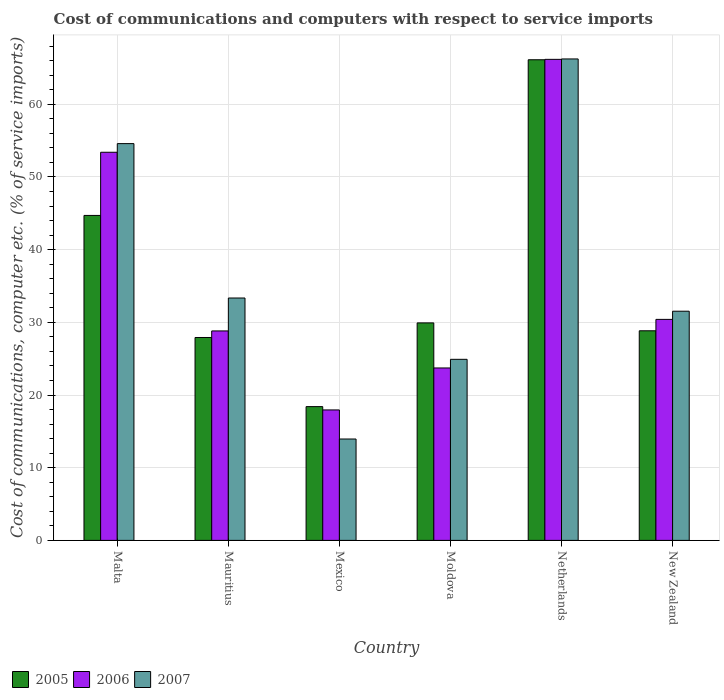How many groups of bars are there?
Your answer should be very brief. 6. How many bars are there on the 6th tick from the left?
Your answer should be very brief. 3. What is the label of the 2nd group of bars from the left?
Offer a terse response. Mauritius. In how many cases, is the number of bars for a given country not equal to the number of legend labels?
Offer a terse response. 0. What is the cost of communications and computers in 2006 in Mexico?
Your answer should be very brief. 17.95. Across all countries, what is the maximum cost of communications and computers in 2007?
Provide a succinct answer. 66.23. Across all countries, what is the minimum cost of communications and computers in 2005?
Offer a terse response. 18.4. In which country was the cost of communications and computers in 2005 minimum?
Offer a very short reply. Mexico. What is the total cost of communications and computers in 2006 in the graph?
Ensure brevity in your answer.  220.46. What is the difference between the cost of communications and computers in 2007 in Moldova and that in Netherlands?
Provide a succinct answer. -41.32. What is the difference between the cost of communications and computers in 2005 in Mexico and the cost of communications and computers in 2007 in Mauritius?
Provide a short and direct response. -14.94. What is the average cost of communications and computers in 2006 per country?
Your answer should be compact. 36.74. What is the difference between the cost of communications and computers of/in 2006 and cost of communications and computers of/in 2005 in Malta?
Give a very brief answer. 8.69. In how many countries, is the cost of communications and computers in 2007 greater than 34 %?
Give a very brief answer. 2. What is the ratio of the cost of communications and computers in 2007 in Mexico to that in Moldova?
Make the answer very short. 0.56. Is the difference between the cost of communications and computers in 2006 in Moldova and New Zealand greater than the difference between the cost of communications and computers in 2005 in Moldova and New Zealand?
Your response must be concise. No. What is the difference between the highest and the second highest cost of communications and computers in 2005?
Your answer should be compact. 21.42. What is the difference between the highest and the lowest cost of communications and computers in 2005?
Offer a terse response. 47.72. What does the 2nd bar from the left in Mexico represents?
Make the answer very short. 2006. What is the difference between two consecutive major ticks on the Y-axis?
Keep it short and to the point. 10. Are the values on the major ticks of Y-axis written in scientific E-notation?
Offer a terse response. No. How many legend labels are there?
Provide a short and direct response. 3. How are the legend labels stacked?
Provide a short and direct response. Horizontal. What is the title of the graph?
Keep it short and to the point. Cost of communications and computers with respect to service imports. What is the label or title of the Y-axis?
Ensure brevity in your answer.  Cost of communications, computer etc. (% of service imports). What is the Cost of communications, computer etc. (% of service imports) in 2005 in Malta?
Offer a terse response. 44.71. What is the Cost of communications, computer etc. (% of service imports) of 2006 in Malta?
Your response must be concise. 53.4. What is the Cost of communications, computer etc. (% of service imports) of 2007 in Malta?
Your answer should be compact. 54.58. What is the Cost of communications, computer etc. (% of service imports) in 2005 in Mauritius?
Your answer should be very brief. 27.91. What is the Cost of communications, computer etc. (% of service imports) of 2006 in Mauritius?
Your answer should be very brief. 28.82. What is the Cost of communications, computer etc. (% of service imports) in 2007 in Mauritius?
Your answer should be very brief. 33.35. What is the Cost of communications, computer etc. (% of service imports) of 2005 in Mexico?
Your answer should be compact. 18.4. What is the Cost of communications, computer etc. (% of service imports) in 2006 in Mexico?
Offer a terse response. 17.95. What is the Cost of communications, computer etc. (% of service imports) in 2007 in Mexico?
Give a very brief answer. 13.95. What is the Cost of communications, computer etc. (% of service imports) in 2005 in Moldova?
Your answer should be compact. 29.92. What is the Cost of communications, computer etc. (% of service imports) in 2006 in Moldova?
Offer a terse response. 23.72. What is the Cost of communications, computer etc. (% of service imports) in 2007 in Moldova?
Offer a very short reply. 24.91. What is the Cost of communications, computer etc. (% of service imports) in 2005 in Netherlands?
Your answer should be very brief. 66.12. What is the Cost of communications, computer etc. (% of service imports) of 2006 in Netherlands?
Your response must be concise. 66.18. What is the Cost of communications, computer etc. (% of service imports) of 2007 in Netherlands?
Offer a terse response. 66.23. What is the Cost of communications, computer etc. (% of service imports) in 2005 in New Zealand?
Provide a short and direct response. 28.84. What is the Cost of communications, computer etc. (% of service imports) in 2006 in New Zealand?
Keep it short and to the point. 30.4. What is the Cost of communications, computer etc. (% of service imports) of 2007 in New Zealand?
Make the answer very short. 31.53. Across all countries, what is the maximum Cost of communications, computer etc. (% of service imports) in 2005?
Your response must be concise. 66.12. Across all countries, what is the maximum Cost of communications, computer etc. (% of service imports) in 2006?
Your answer should be very brief. 66.18. Across all countries, what is the maximum Cost of communications, computer etc. (% of service imports) of 2007?
Give a very brief answer. 66.23. Across all countries, what is the minimum Cost of communications, computer etc. (% of service imports) in 2005?
Offer a very short reply. 18.4. Across all countries, what is the minimum Cost of communications, computer etc. (% of service imports) in 2006?
Your answer should be compact. 17.95. Across all countries, what is the minimum Cost of communications, computer etc. (% of service imports) of 2007?
Make the answer very short. 13.95. What is the total Cost of communications, computer etc. (% of service imports) of 2005 in the graph?
Provide a succinct answer. 215.9. What is the total Cost of communications, computer etc. (% of service imports) in 2006 in the graph?
Provide a succinct answer. 220.46. What is the total Cost of communications, computer etc. (% of service imports) of 2007 in the graph?
Provide a succinct answer. 224.55. What is the difference between the Cost of communications, computer etc. (% of service imports) in 2005 in Malta and that in Mauritius?
Your answer should be very brief. 16.79. What is the difference between the Cost of communications, computer etc. (% of service imports) of 2006 in Malta and that in Mauritius?
Make the answer very short. 24.58. What is the difference between the Cost of communications, computer etc. (% of service imports) in 2007 in Malta and that in Mauritius?
Make the answer very short. 21.24. What is the difference between the Cost of communications, computer etc. (% of service imports) in 2005 in Malta and that in Mexico?
Your answer should be compact. 26.3. What is the difference between the Cost of communications, computer etc. (% of service imports) of 2006 in Malta and that in Mexico?
Make the answer very short. 35.45. What is the difference between the Cost of communications, computer etc. (% of service imports) of 2007 in Malta and that in Mexico?
Your answer should be compact. 40.64. What is the difference between the Cost of communications, computer etc. (% of service imports) of 2005 in Malta and that in Moldova?
Keep it short and to the point. 14.79. What is the difference between the Cost of communications, computer etc. (% of service imports) of 2006 in Malta and that in Moldova?
Offer a very short reply. 29.67. What is the difference between the Cost of communications, computer etc. (% of service imports) in 2007 in Malta and that in Moldova?
Ensure brevity in your answer.  29.67. What is the difference between the Cost of communications, computer etc. (% of service imports) of 2005 in Malta and that in Netherlands?
Ensure brevity in your answer.  -21.42. What is the difference between the Cost of communications, computer etc. (% of service imports) in 2006 in Malta and that in Netherlands?
Provide a succinct answer. -12.78. What is the difference between the Cost of communications, computer etc. (% of service imports) of 2007 in Malta and that in Netherlands?
Provide a short and direct response. -11.65. What is the difference between the Cost of communications, computer etc. (% of service imports) in 2005 in Malta and that in New Zealand?
Make the answer very short. 15.87. What is the difference between the Cost of communications, computer etc. (% of service imports) of 2006 in Malta and that in New Zealand?
Keep it short and to the point. 22.99. What is the difference between the Cost of communications, computer etc. (% of service imports) in 2007 in Malta and that in New Zealand?
Your answer should be very brief. 23.06. What is the difference between the Cost of communications, computer etc. (% of service imports) of 2005 in Mauritius and that in Mexico?
Offer a very short reply. 9.51. What is the difference between the Cost of communications, computer etc. (% of service imports) in 2006 in Mauritius and that in Mexico?
Give a very brief answer. 10.87. What is the difference between the Cost of communications, computer etc. (% of service imports) in 2007 in Mauritius and that in Mexico?
Your response must be concise. 19.4. What is the difference between the Cost of communications, computer etc. (% of service imports) of 2005 in Mauritius and that in Moldova?
Keep it short and to the point. -2.01. What is the difference between the Cost of communications, computer etc. (% of service imports) in 2006 in Mauritius and that in Moldova?
Provide a succinct answer. 5.09. What is the difference between the Cost of communications, computer etc. (% of service imports) in 2007 in Mauritius and that in Moldova?
Your response must be concise. 8.44. What is the difference between the Cost of communications, computer etc. (% of service imports) in 2005 in Mauritius and that in Netherlands?
Give a very brief answer. -38.21. What is the difference between the Cost of communications, computer etc. (% of service imports) in 2006 in Mauritius and that in Netherlands?
Your answer should be very brief. -37.36. What is the difference between the Cost of communications, computer etc. (% of service imports) of 2007 in Mauritius and that in Netherlands?
Your answer should be very brief. -32.89. What is the difference between the Cost of communications, computer etc. (% of service imports) in 2005 in Mauritius and that in New Zealand?
Give a very brief answer. -0.92. What is the difference between the Cost of communications, computer etc. (% of service imports) in 2006 in Mauritius and that in New Zealand?
Ensure brevity in your answer.  -1.59. What is the difference between the Cost of communications, computer etc. (% of service imports) in 2007 in Mauritius and that in New Zealand?
Your response must be concise. 1.82. What is the difference between the Cost of communications, computer etc. (% of service imports) of 2005 in Mexico and that in Moldova?
Your response must be concise. -11.52. What is the difference between the Cost of communications, computer etc. (% of service imports) of 2006 in Mexico and that in Moldova?
Your answer should be very brief. -5.77. What is the difference between the Cost of communications, computer etc. (% of service imports) of 2007 in Mexico and that in Moldova?
Your response must be concise. -10.96. What is the difference between the Cost of communications, computer etc. (% of service imports) of 2005 in Mexico and that in Netherlands?
Make the answer very short. -47.72. What is the difference between the Cost of communications, computer etc. (% of service imports) in 2006 in Mexico and that in Netherlands?
Ensure brevity in your answer.  -48.23. What is the difference between the Cost of communications, computer etc. (% of service imports) of 2007 in Mexico and that in Netherlands?
Provide a short and direct response. -52.29. What is the difference between the Cost of communications, computer etc. (% of service imports) of 2005 in Mexico and that in New Zealand?
Offer a terse response. -10.43. What is the difference between the Cost of communications, computer etc. (% of service imports) of 2006 in Mexico and that in New Zealand?
Your answer should be very brief. -12.46. What is the difference between the Cost of communications, computer etc. (% of service imports) in 2007 in Mexico and that in New Zealand?
Keep it short and to the point. -17.58. What is the difference between the Cost of communications, computer etc. (% of service imports) of 2005 in Moldova and that in Netherlands?
Offer a very short reply. -36.2. What is the difference between the Cost of communications, computer etc. (% of service imports) of 2006 in Moldova and that in Netherlands?
Provide a short and direct response. -42.46. What is the difference between the Cost of communications, computer etc. (% of service imports) in 2007 in Moldova and that in Netherlands?
Give a very brief answer. -41.32. What is the difference between the Cost of communications, computer etc. (% of service imports) of 2005 in Moldova and that in New Zealand?
Your response must be concise. 1.08. What is the difference between the Cost of communications, computer etc. (% of service imports) in 2006 in Moldova and that in New Zealand?
Offer a terse response. -6.68. What is the difference between the Cost of communications, computer etc. (% of service imports) of 2007 in Moldova and that in New Zealand?
Your answer should be compact. -6.62. What is the difference between the Cost of communications, computer etc. (% of service imports) in 2005 in Netherlands and that in New Zealand?
Offer a terse response. 37.29. What is the difference between the Cost of communications, computer etc. (% of service imports) in 2006 in Netherlands and that in New Zealand?
Your answer should be very brief. 35.77. What is the difference between the Cost of communications, computer etc. (% of service imports) of 2007 in Netherlands and that in New Zealand?
Your answer should be very brief. 34.7. What is the difference between the Cost of communications, computer etc. (% of service imports) in 2005 in Malta and the Cost of communications, computer etc. (% of service imports) in 2006 in Mauritius?
Give a very brief answer. 15.89. What is the difference between the Cost of communications, computer etc. (% of service imports) in 2005 in Malta and the Cost of communications, computer etc. (% of service imports) in 2007 in Mauritius?
Your answer should be very brief. 11.36. What is the difference between the Cost of communications, computer etc. (% of service imports) of 2006 in Malta and the Cost of communications, computer etc. (% of service imports) of 2007 in Mauritius?
Your response must be concise. 20.05. What is the difference between the Cost of communications, computer etc. (% of service imports) of 2005 in Malta and the Cost of communications, computer etc. (% of service imports) of 2006 in Mexico?
Your answer should be compact. 26.76. What is the difference between the Cost of communications, computer etc. (% of service imports) of 2005 in Malta and the Cost of communications, computer etc. (% of service imports) of 2007 in Mexico?
Offer a very short reply. 30.76. What is the difference between the Cost of communications, computer etc. (% of service imports) in 2006 in Malta and the Cost of communications, computer etc. (% of service imports) in 2007 in Mexico?
Your answer should be very brief. 39.45. What is the difference between the Cost of communications, computer etc. (% of service imports) in 2005 in Malta and the Cost of communications, computer etc. (% of service imports) in 2006 in Moldova?
Give a very brief answer. 20.99. What is the difference between the Cost of communications, computer etc. (% of service imports) of 2005 in Malta and the Cost of communications, computer etc. (% of service imports) of 2007 in Moldova?
Your answer should be compact. 19.8. What is the difference between the Cost of communications, computer etc. (% of service imports) in 2006 in Malta and the Cost of communications, computer etc. (% of service imports) in 2007 in Moldova?
Your answer should be compact. 28.49. What is the difference between the Cost of communications, computer etc. (% of service imports) in 2005 in Malta and the Cost of communications, computer etc. (% of service imports) in 2006 in Netherlands?
Your answer should be very brief. -21.47. What is the difference between the Cost of communications, computer etc. (% of service imports) in 2005 in Malta and the Cost of communications, computer etc. (% of service imports) in 2007 in Netherlands?
Offer a terse response. -21.53. What is the difference between the Cost of communications, computer etc. (% of service imports) in 2006 in Malta and the Cost of communications, computer etc. (% of service imports) in 2007 in Netherlands?
Ensure brevity in your answer.  -12.84. What is the difference between the Cost of communications, computer etc. (% of service imports) in 2005 in Malta and the Cost of communications, computer etc. (% of service imports) in 2006 in New Zealand?
Give a very brief answer. 14.3. What is the difference between the Cost of communications, computer etc. (% of service imports) of 2005 in Malta and the Cost of communications, computer etc. (% of service imports) of 2007 in New Zealand?
Offer a terse response. 13.18. What is the difference between the Cost of communications, computer etc. (% of service imports) of 2006 in Malta and the Cost of communications, computer etc. (% of service imports) of 2007 in New Zealand?
Provide a short and direct response. 21.87. What is the difference between the Cost of communications, computer etc. (% of service imports) of 2005 in Mauritius and the Cost of communications, computer etc. (% of service imports) of 2006 in Mexico?
Give a very brief answer. 9.97. What is the difference between the Cost of communications, computer etc. (% of service imports) of 2005 in Mauritius and the Cost of communications, computer etc. (% of service imports) of 2007 in Mexico?
Offer a terse response. 13.97. What is the difference between the Cost of communications, computer etc. (% of service imports) in 2006 in Mauritius and the Cost of communications, computer etc. (% of service imports) in 2007 in Mexico?
Your response must be concise. 14.87. What is the difference between the Cost of communications, computer etc. (% of service imports) in 2005 in Mauritius and the Cost of communications, computer etc. (% of service imports) in 2006 in Moldova?
Your response must be concise. 4.19. What is the difference between the Cost of communications, computer etc. (% of service imports) of 2005 in Mauritius and the Cost of communications, computer etc. (% of service imports) of 2007 in Moldova?
Give a very brief answer. 3. What is the difference between the Cost of communications, computer etc. (% of service imports) in 2006 in Mauritius and the Cost of communications, computer etc. (% of service imports) in 2007 in Moldova?
Provide a short and direct response. 3.91. What is the difference between the Cost of communications, computer etc. (% of service imports) of 2005 in Mauritius and the Cost of communications, computer etc. (% of service imports) of 2006 in Netherlands?
Offer a terse response. -38.26. What is the difference between the Cost of communications, computer etc. (% of service imports) in 2005 in Mauritius and the Cost of communications, computer etc. (% of service imports) in 2007 in Netherlands?
Provide a succinct answer. -38.32. What is the difference between the Cost of communications, computer etc. (% of service imports) in 2006 in Mauritius and the Cost of communications, computer etc. (% of service imports) in 2007 in Netherlands?
Ensure brevity in your answer.  -37.42. What is the difference between the Cost of communications, computer etc. (% of service imports) in 2005 in Mauritius and the Cost of communications, computer etc. (% of service imports) in 2006 in New Zealand?
Offer a terse response. -2.49. What is the difference between the Cost of communications, computer etc. (% of service imports) in 2005 in Mauritius and the Cost of communications, computer etc. (% of service imports) in 2007 in New Zealand?
Ensure brevity in your answer.  -3.61. What is the difference between the Cost of communications, computer etc. (% of service imports) of 2006 in Mauritius and the Cost of communications, computer etc. (% of service imports) of 2007 in New Zealand?
Your answer should be very brief. -2.71. What is the difference between the Cost of communications, computer etc. (% of service imports) of 2005 in Mexico and the Cost of communications, computer etc. (% of service imports) of 2006 in Moldova?
Offer a terse response. -5.32. What is the difference between the Cost of communications, computer etc. (% of service imports) in 2005 in Mexico and the Cost of communications, computer etc. (% of service imports) in 2007 in Moldova?
Offer a very short reply. -6.51. What is the difference between the Cost of communications, computer etc. (% of service imports) of 2006 in Mexico and the Cost of communications, computer etc. (% of service imports) of 2007 in Moldova?
Ensure brevity in your answer.  -6.96. What is the difference between the Cost of communications, computer etc. (% of service imports) of 2005 in Mexico and the Cost of communications, computer etc. (% of service imports) of 2006 in Netherlands?
Your response must be concise. -47.77. What is the difference between the Cost of communications, computer etc. (% of service imports) of 2005 in Mexico and the Cost of communications, computer etc. (% of service imports) of 2007 in Netherlands?
Ensure brevity in your answer.  -47.83. What is the difference between the Cost of communications, computer etc. (% of service imports) in 2006 in Mexico and the Cost of communications, computer etc. (% of service imports) in 2007 in Netherlands?
Keep it short and to the point. -48.29. What is the difference between the Cost of communications, computer etc. (% of service imports) in 2005 in Mexico and the Cost of communications, computer etc. (% of service imports) in 2006 in New Zealand?
Keep it short and to the point. -12. What is the difference between the Cost of communications, computer etc. (% of service imports) in 2005 in Mexico and the Cost of communications, computer etc. (% of service imports) in 2007 in New Zealand?
Your answer should be very brief. -13.13. What is the difference between the Cost of communications, computer etc. (% of service imports) in 2006 in Mexico and the Cost of communications, computer etc. (% of service imports) in 2007 in New Zealand?
Your answer should be compact. -13.58. What is the difference between the Cost of communications, computer etc. (% of service imports) of 2005 in Moldova and the Cost of communications, computer etc. (% of service imports) of 2006 in Netherlands?
Offer a very short reply. -36.26. What is the difference between the Cost of communications, computer etc. (% of service imports) of 2005 in Moldova and the Cost of communications, computer etc. (% of service imports) of 2007 in Netherlands?
Offer a very short reply. -36.31. What is the difference between the Cost of communications, computer etc. (% of service imports) in 2006 in Moldova and the Cost of communications, computer etc. (% of service imports) in 2007 in Netherlands?
Make the answer very short. -42.51. What is the difference between the Cost of communications, computer etc. (% of service imports) of 2005 in Moldova and the Cost of communications, computer etc. (% of service imports) of 2006 in New Zealand?
Keep it short and to the point. -0.48. What is the difference between the Cost of communications, computer etc. (% of service imports) in 2005 in Moldova and the Cost of communications, computer etc. (% of service imports) in 2007 in New Zealand?
Make the answer very short. -1.61. What is the difference between the Cost of communications, computer etc. (% of service imports) of 2006 in Moldova and the Cost of communications, computer etc. (% of service imports) of 2007 in New Zealand?
Provide a succinct answer. -7.81. What is the difference between the Cost of communications, computer etc. (% of service imports) of 2005 in Netherlands and the Cost of communications, computer etc. (% of service imports) of 2006 in New Zealand?
Keep it short and to the point. 35.72. What is the difference between the Cost of communications, computer etc. (% of service imports) of 2005 in Netherlands and the Cost of communications, computer etc. (% of service imports) of 2007 in New Zealand?
Keep it short and to the point. 34.59. What is the difference between the Cost of communications, computer etc. (% of service imports) of 2006 in Netherlands and the Cost of communications, computer etc. (% of service imports) of 2007 in New Zealand?
Your answer should be compact. 34.65. What is the average Cost of communications, computer etc. (% of service imports) in 2005 per country?
Provide a succinct answer. 35.98. What is the average Cost of communications, computer etc. (% of service imports) in 2006 per country?
Offer a very short reply. 36.74. What is the average Cost of communications, computer etc. (% of service imports) of 2007 per country?
Provide a short and direct response. 37.42. What is the difference between the Cost of communications, computer etc. (% of service imports) of 2005 and Cost of communications, computer etc. (% of service imports) of 2006 in Malta?
Provide a short and direct response. -8.69. What is the difference between the Cost of communications, computer etc. (% of service imports) of 2005 and Cost of communications, computer etc. (% of service imports) of 2007 in Malta?
Keep it short and to the point. -9.88. What is the difference between the Cost of communications, computer etc. (% of service imports) of 2006 and Cost of communications, computer etc. (% of service imports) of 2007 in Malta?
Provide a short and direct response. -1.19. What is the difference between the Cost of communications, computer etc. (% of service imports) in 2005 and Cost of communications, computer etc. (% of service imports) in 2006 in Mauritius?
Offer a terse response. -0.9. What is the difference between the Cost of communications, computer etc. (% of service imports) in 2005 and Cost of communications, computer etc. (% of service imports) in 2007 in Mauritius?
Make the answer very short. -5.43. What is the difference between the Cost of communications, computer etc. (% of service imports) in 2006 and Cost of communications, computer etc. (% of service imports) in 2007 in Mauritius?
Provide a short and direct response. -4.53. What is the difference between the Cost of communications, computer etc. (% of service imports) of 2005 and Cost of communications, computer etc. (% of service imports) of 2006 in Mexico?
Your answer should be very brief. 0.46. What is the difference between the Cost of communications, computer etc. (% of service imports) of 2005 and Cost of communications, computer etc. (% of service imports) of 2007 in Mexico?
Provide a succinct answer. 4.46. What is the difference between the Cost of communications, computer etc. (% of service imports) of 2006 and Cost of communications, computer etc. (% of service imports) of 2007 in Mexico?
Give a very brief answer. 4. What is the difference between the Cost of communications, computer etc. (% of service imports) in 2005 and Cost of communications, computer etc. (% of service imports) in 2007 in Moldova?
Offer a very short reply. 5.01. What is the difference between the Cost of communications, computer etc. (% of service imports) of 2006 and Cost of communications, computer etc. (% of service imports) of 2007 in Moldova?
Your answer should be very brief. -1.19. What is the difference between the Cost of communications, computer etc. (% of service imports) of 2005 and Cost of communications, computer etc. (% of service imports) of 2006 in Netherlands?
Offer a very short reply. -0.05. What is the difference between the Cost of communications, computer etc. (% of service imports) of 2005 and Cost of communications, computer etc. (% of service imports) of 2007 in Netherlands?
Provide a short and direct response. -0.11. What is the difference between the Cost of communications, computer etc. (% of service imports) in 2006 and Cost of communications, computer etc. (% of service imports) in 2007 in Netherlands?
Provide a succinct answer. -0.06. What is the difference between the Cost of communications, computer etc. (% of service imports) in 2005 and Cost of communications, computer etc. (% of service imports) in 2006 in New Zealand?
Make the answer very short. -1.57. What is the difference between the Cost of communications, computer etc. (% of service imports) in 2005 and Cost of communications, computer etc. (% of service imports) in 2007 in New Zealand?
Offer a terse response. -2.69. What is the difference between the Cost of communications, computer etc. (% of service imports) of 2006 and Cost of communications, computer etc. (% of service imports) of 2007 in New Zealand?
Make the answer very short. -1.12. What is the ratio of the Cost of communications, computer etc. (% of service imports) in 2005 in Malta to that in Mauritius?
Make the answer very short. 1.6. What is the ratio of the Cost of communications, computer etc. (% of service imports) of 2006 in Malta to that in Mauritius?
Ensure brevity in your answer.  1.85. What is the ratio of the Cost of communications, computer etc. (% of service imports) of 2007 in Malta to that in Mauritius?
Offer a very short reply. 1.64. What is the ratio of the Cost of communications, computer etc. (% of service imports) of 2005 in Malta to that in Mexico?
Your answer should be compact. 2.43. What is the ratio of the Cost of communications, computer etc. (% of service imports) of 2006 in Malta to that in Mexico?
Keep it short and to the point. 2.98. What is the ratio of the Cost of communications, computer etc. (% of service imports) in 2007 in Malta to that in Mexico?
Provide a succinct answer. 3.91. What is the ratio of the Cost of communications, computer etc. (% of service imports) in 2005 in Malta to that in Moldova?
Give a very brief answer. 1.49. What is the ratio of the Cost of communications, computer etc. (% of service imports) of 2006 in Malta to that in Moldova?
Ensure brevity in your answer.  2.25. What is the ratio of the Cost of communications, computer etc. (% of service imports) of 2007 in Malta to that in Moldova?
Provide a short and direct response. 2.19. What is the ratio of the Cost of communications, computer etc. (% of service imports) in 2005 in Malta to that in Netherlands?
Provide a succinct answer. 0.68. What is the ratio of the Cost of communications, computer etc. (% of service imports) in 2006 in Malta to that in Netherlands?
Provide a short and direct response. 0.81. What is the ratio of the Cost of communications, computer etc. (% of service imports) in 2007 in Malta to that in Netherlands?
Provide a short and direct response. 0.82. What is the ratio of the Cost of communications, computer etc. (% of service imports) of 2005 in Malta to that in New Zealand?
Offer a very short reply. 1.55. What is the ratio of the Cost of communications, computer etc. (% of service imports) in 2006 in Malta to that in New Zealand?
Offer a terse response. 1.76. What is the ratio of the Cost of communications, computer etc. (% of service imports) of 2007 in Malta to that in New Zealand?
Give a very brief answer. 1.73. What is the ratio of the Cost of communications, computer etc. (% of service imports) of 2005 in Mauritius to that in Mexico?
Make the answer very short. 1.52. What is the ratio of the Cost of communications, computer etc. (% of service imports) in 2006 in Mauritius to that in Mexico?
Ensure brevity in your answer.  1.61. What is the ratio of the Cost of communications, computer etc. (% of service imports) in 2007 in Mauritius to that in Mexico?
Your answer should be very brief. 2.39. What is the ratio of the Cost of communications, computer etc. (% of service imports) of 2005 in Mauritius to that in Moldova?
Your response must be concise. 0.93. What is the ratio of the Cost of communications, computer etc. (% of service imports) of 2006 in Mauritius to that in Moldova?
Ensure brevity in your answer.  1.21. What is the ratio of the Cost of communications, computer etc. (% of service imports) in 2007 in Mauritius to that in Moldova?
Ensure brevity in your answer.  1.34. What is the ratio of the Cost of communications, computer etc. (% of service imports) of 2005 in Mauritius to that in Netherlands?
Offer a terse response. 0.42. What is the ratio of the Cost of communications, computer etc. (% of service imports) in 2006 in Mauritius to that in Netherlands?
Give a very brief answer. 0.44. What is the ratio of the Cost of communications, computer etc. (% of service imports) of 2007 in Mauritius to that in Netherlands?
Offer a very short reply. 0.5. What is the ratio of the Cost of communications, computer etc. (% of service imports) of 2005 in Mauritius to that in New Zealand?
Give a very brief answer. 0.97. What is the ratio of the Cost of communications, computer etc. (% of service imports) of 2006 in Mauritius to that in New Zealand?
Your response must be concise. 0.95. What is the ratio of the Cost of communications, computer etc. (% of service imports) of 2007 in Mauritius to that in New Zealand?
Provide a succinct answer. 1.06. What is the ratio of the Cost of communications, computer etc. (% of service imports) in 2005 in Mexico to that in Moldova?
Your response must be concise. 0.61. What is the ratio of the Cost of communications, computer etc. (% of service imports) of 2006 in Mexico to that in Moldova?
Your answer should be compact. 0.76. What is the ratio of the Cost of communications, computer etc. (% of service imports) in 2007 in Mexico to that in Moldova?
Provide a short and direct response. 0.56. What is the ratio of the Cost of communications, computer etc. (% of service imports) of 2005 in Mexico to that in Netherlands?
Provide a succinct answer. 0.28. What is the ratio of the Cost of communications, computer etc. (% of service imports) in 2006 in Mexico to that in Netherlands?
Provide a short and direct response. 0.27. What is the ratio of the Cost of communications, computer etc. (% of service imports) of 2007 in Mexico to that in Netherlands?
Your response must be concise. 0.21. What is the ratio of the Cost of communications, computer etc. (% of service imports) in 2005 in Mexico to that in New Zealand?
Your answer should be very brief. 0.64. What is the ratio of the Cost of communications, computer etc. (% of service imports) in 2006 in Mexico to that in New Zealand?
Give a very brief answer. 0.59. What is the ratio of the Cost of communications, computer etc. (% of service imports) in 2007 in Mexico to that in New Zealand?
Your answer should be compact. 0.44. What is the ratio of the Cost of communications, computer etc. (% of service imports) of 2005 in Moldova to that in Netherlands?
Your answer should be compact. 0.45. What is the ratio of the Cost of communications, computer etc. (% of service imports) in 2006 in Moldova to that in Netherlands?
Offer a very short reply. 0.36. What is the ratio of the Cost of communications, computer etc. (% of service imports) of 2007 in Moldova to that in Netherlands?
Provide a succinct answer. 0.38. What is the ratio of the Cost of communications, computer etc. (% of service imports) in 2005 in Moldova to that in New Zealand?
Offer a terse response. 1.04. What is the ratio of the Cost of communications, computer etc. (% of service imports) in 2006 in Moldova to that in New Zealand?
Keep it short and to the point. 0.78. What is the ratio of the Cost of communications, computer etc. (% of service imports) in 2007 in Moldova to that in New Zealand?
Give a very brief answer. 0.79. What is the ratio of the Cost of communications, computer etc. (% of service imports) in 2005 in Netherlands to that in New Zealand?
Your response must be concise. 2.29. What is the ratio of the Cost of communications, computer etc. (% of service imports) in 2006 in Netherlands to that in New Zealand?
Give a very brief answer. 2.18. What is the ratio of the Cost of communications, computer etc. (% of service imports) in 2007 in Netherlands to that in New Zealand?
Provide a succinct answer. 2.1. What is the difference between the highest and the second highest Cost of communications, computer etc. (% of service imports) in 2005?
Offer a very short reply. 21.42. What is the difference between the highest and the second highest Cost of communications, computer etc. (% of service imports) of 2006?
Your answer should be very brief. 12.78. What is the difference between the highest and the second highest Cost of communications, computer etc. (% of service imports) of 2007?
Your response must be concise. 11.65. What is the difference between the highest and the lowest Cost of communications, computer etc. (% of service imports) of 2005?
Give a very brief answer. 47.72. What is the difference between the highest and the lowest Cost of communications, computer etc. (% of service imports) of 2006?
Your answer should be compact. 48.23. What is the difference between the highest and the lowest Cost of communications, computer etc. (% of service imports) in 2007?
Your answer should be compact. 52.29. 